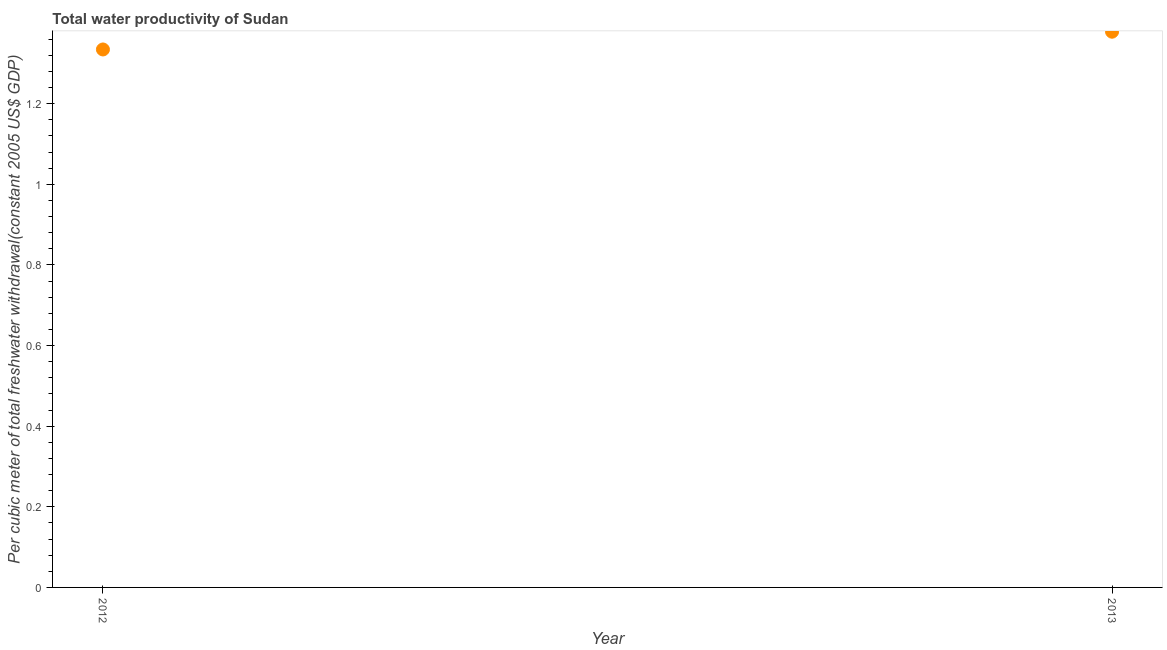What is the total water productivity in 2013?
Offer a terse response. 1.38. Across all years, what is the maximum total water productivity?
Your response must be concise. 1.38. Across all years, what is the minimum total water productivity?
Your response must be concise. 1.33. In which year was the total water productivity maximum?
Provide a short and direct response. 2013. What is the sum of the total water productivity?
Your answer should be compact. 2.71. What is the difference between the total water productivity in 2012 and 2013?
Provide a succinct answer. -0.04. What is the average total water productivity per year?
Give a very brief answer. 1.36. What is the median total water productivity?
Your answer should be compact. 1.36. What is the ratio of the total water productivity in 2012 to that in 2013?
Offer a terse response. 0.97. Does the total water productivity monotonically increase over the years?
Make the answer very short. Yes. How many dotlines are there?
Keep it short and to the point. 1. How many years are there in the graph?
Offer a terse response. 2. Does the graph contain grids?
Provide a short and direct response. No. What is the title of the graph?
Provide a short and direct response. Total water productivity of Sudan. What is the label or title of the X-axis?
Provide a succinct answer. Year. What is the label or title of the Y-axis?
Your answer should be compact. Per cubic meter of total freshwater withdrawal(constant 2005 US$ GDP). What is the Per cubic meter of total freshwater withdrawal(constant 2005 US$ GDP) in 2012?
Ensure brevity in your answer.  1.33. What is the Per cubic meter of total freshwater withdrawal(constant 2005 US$ GDP) in 2013?
Ensure brevity in your answer.  1.38. What is the difference between the Per cubic meter of total freshwater withdrawal(constant 2005 US$ GDP) in 2012 and 2013?
Your answer should be very brief. -0.04. 